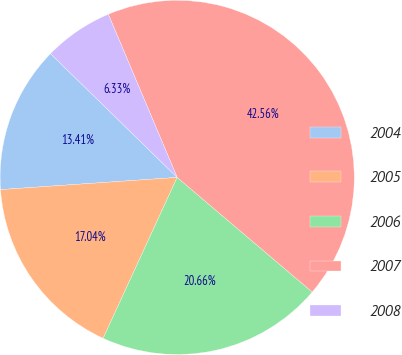Convert chart to OTSL. <chart><loc_0><loc_0><loc_500><loc_500><pie_chart><fcel>2004<fcel>2005<fcel>2006<fcel>2007<fcel>2008<nl><fcel>13.41%<fcel>17.04%<fcel>20.66%<fcel>42.56%<fcel>6.33%<nl></chart> 